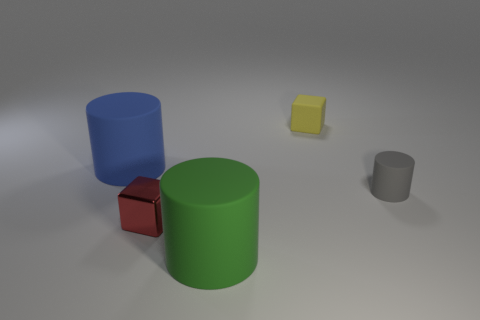Add 3 big blue rubber objects. How many objects exist? 8 Subtract all large rubber cylinders. How many cylinders are left? 1 Subtract all gray cylinders. How many cylinders are left? 2 Subtract all blocks. How many objects are left? 3 Subtract 1 blocks. How many blocks are left? 1 Add 3 tiny rubber things. How many tiny rubber things are left? 5 Add 5 gray matte things. How many gray matte things exist? 6 Subtract 0 gray cubes. How many objects are left? 5 Subtract all brown cylinders. Subtract all purple cubes. How many cylinders are left? 3 Subtract all green cubes. How many brown cylinders are left? 0 